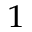<formula> <loc_0><loc_0><loc_500><loc_500>^ { 1 }</formula> 